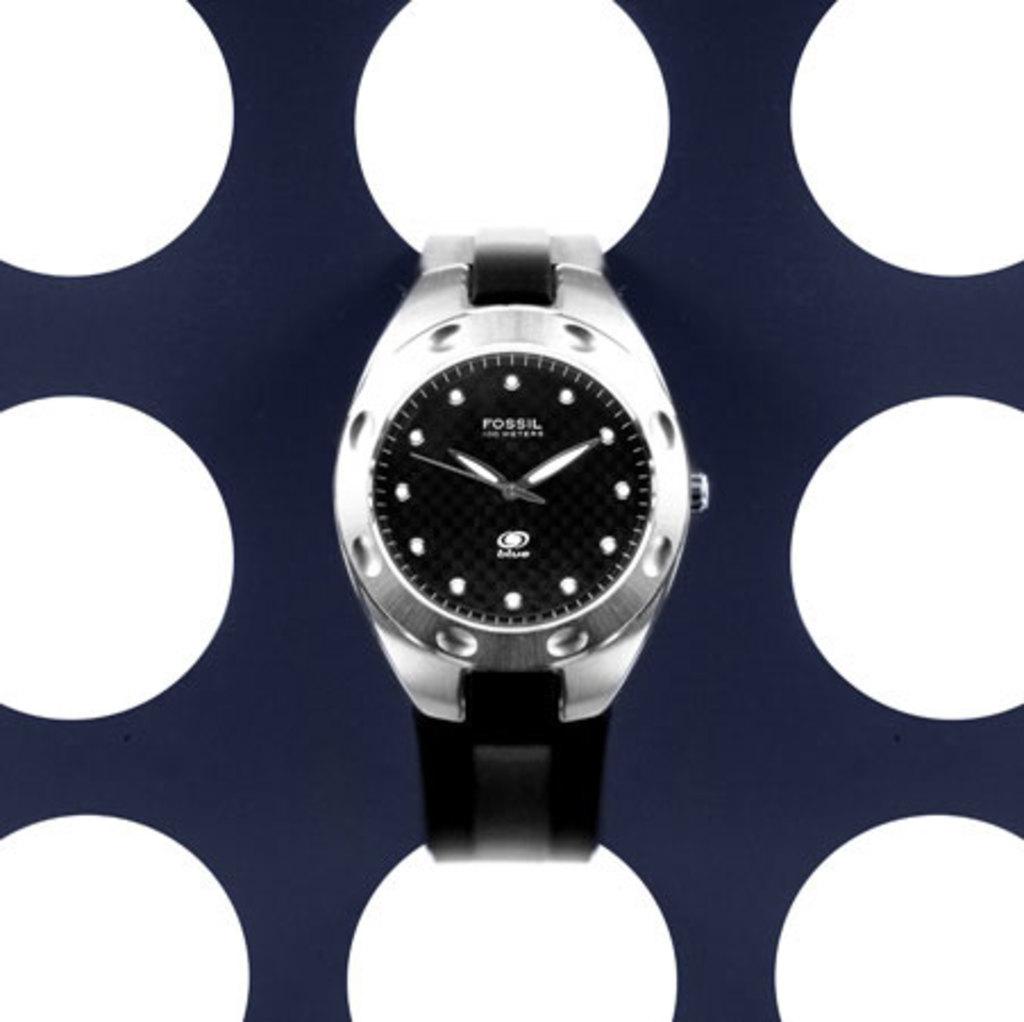What brand is this watch?
Make the answer very short. Fossil. What does the watch say at the top, below the 12 position?
Make the answer very short. Fossil. 